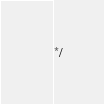Convert code to text. <code><loc_0><loc_0><loc_500><loc_500><_JavaScript_>*/</code> 